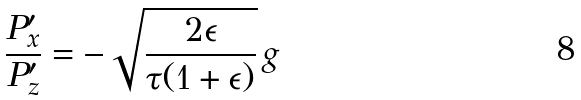<formula> <loc_0><loc_0><loc_500><loc_500>\frac { P ^ { \prime } _ { x } } { P ^ { \prime } _ { z } } = - \sqrt { \frac { 2 \epsilon } { \tau ( 1 + \epsilon ) } } \, g</formula> 